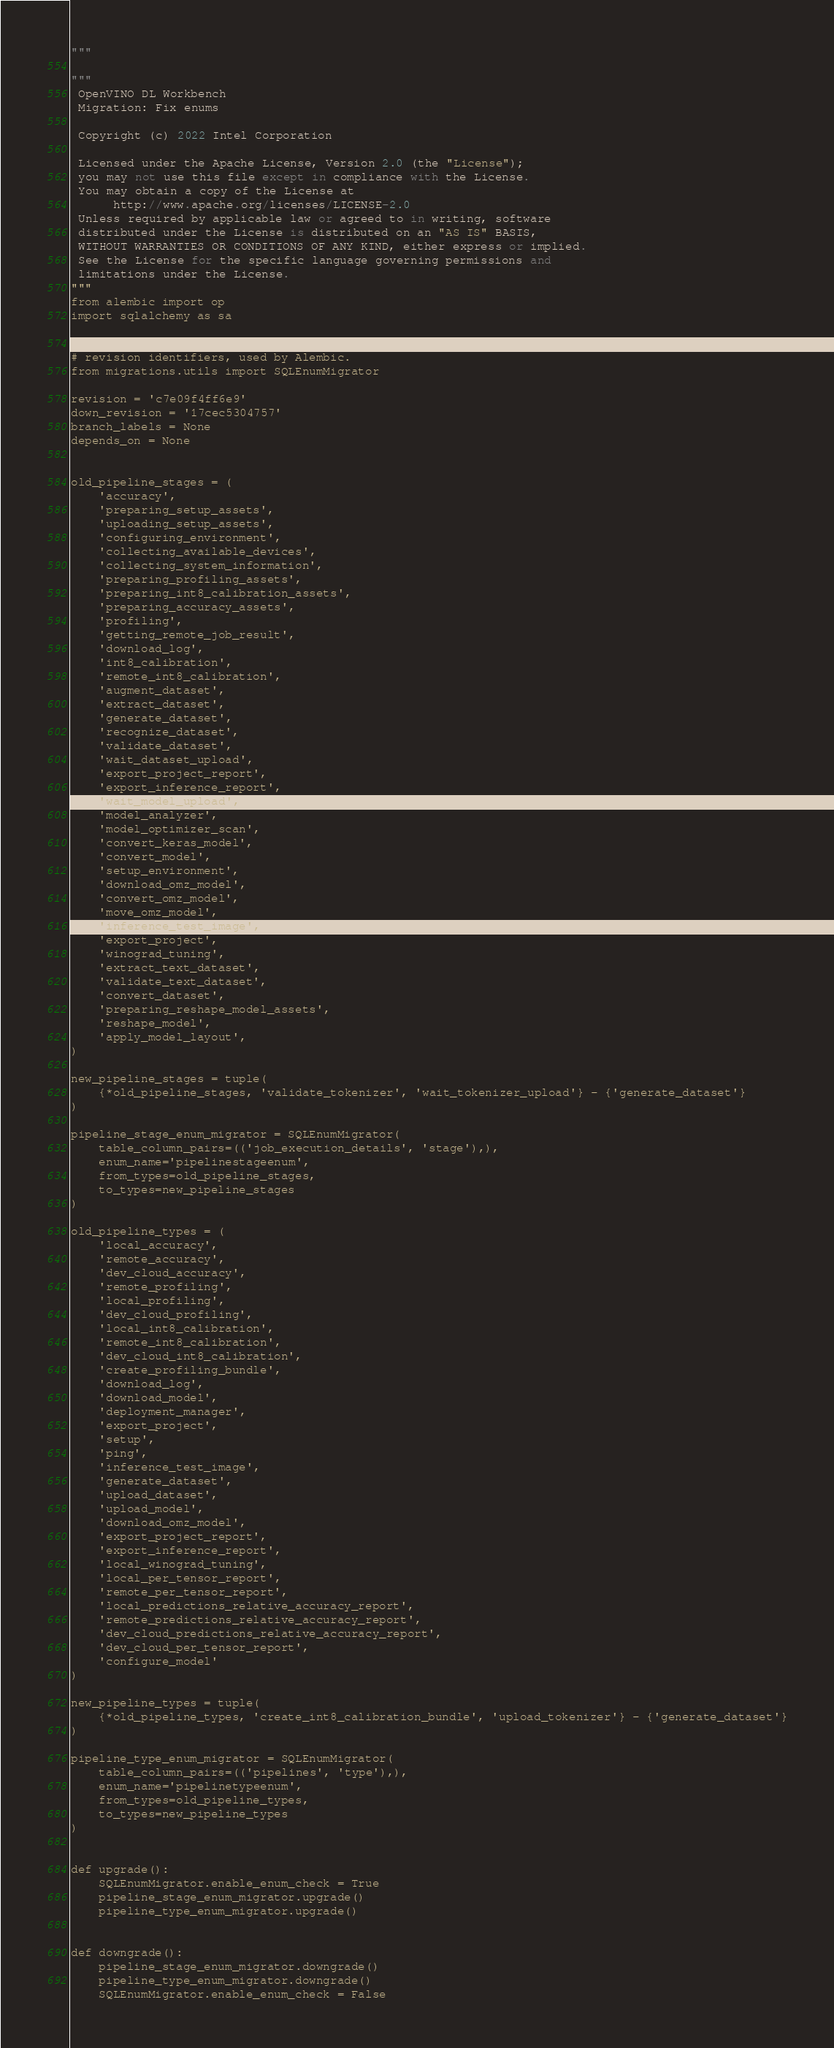Convert code to text. <code><loc_0><loc_0><loc_500><loc_500><_Python_>"""

"""
 OpenVINO DL Workbench
 Migration: Fix enums

 Copyright (c) 2022 Intel Corporation

 Licensed under the Apache License, Version 2.0 (the "License");
 you may not use this file except in compliance with the License.
 You may obtain a copy of the License at
      http://www.apache.org/licenses/LICENSE-2.0
 Unless required by applicable law or agreed to in writing, software
 distributed under the License is distributed on an "AS IS" BASIS,
 WITHOUT WARRANTIES OR CONDITIONS OF ANY KIND, either express or implied.
 See the License for the specific language governing permissions and
 limitations under the License.
"""
from alembic import op
import sqlalchemy as sa


# revision identifiers, used by Alembic.
from migrations.utils import SQLEnumMigrator

revision = 'c7e09f4ff6e9'
down_revision = '17cec5304757'
branch_labels = None
depends_on = None


old_pipeline_stages = (
    'accuracy',
    'preparing_setup_assets',
    'uploading_setup_assets',
    'configuring_environment',
    'collecting_available_devices',
    'collecting_system_information',
    'preparing_profiling_assets',
    'preparing_int8_calibration_assets',
    'preparing_accuracy_assets',
    'profiling',
    'getting_remote_job_result',
    'download_log',
    'int8_calibration',
    'remote_int8_calibration',
    'augment_dataset',
    'extract_dataset',
    'generate_dataset',
    'recognize_dataset',
    'validate_dataset',
    'wait_dataset_upload',
    'export_project_report',
    'export_inference_report',
    'wait_model_upload',
    'model_analyzer',
    'model_optimizer_scan',
    'convert_keras_model',
    'convert_model',
    'setup_environment',
    'download_omz_model',
    'convert_omz_model',
    'move_omz_model',
    'inference_test_image',
    'export_project',
    'winograd_tuning',
    'extract_text_dataset',
    'validate_text_dataset',
    'convert_dataset',
    'preparing_reshape_model_assets',
    'reshape_model',
    'apply_model_layout',
)

new_pipeline_stages = tuple(
    {*old_pipeline_stages, 'validate_tokenizer', 'wait_tokenizer_upload'} - {'generate_dataset'}
)

pipeline_stage_enum_migrator = SQLEnumMigrator(
    table_column_pairs=(('job_execution_details', 'stage'),),
    enum_name='pipelinestageenum',
    from_types=old_pipeline_stages,
    to_types=new_pipeline_stages
)

old_pipeline_types = (
    'local_accuracy',
    'remote_accuracy',
    'dev_cloud_accuracy',
    'remote_profiling',
    'local_profiling',
    'dev_cloud_profiling',
    'local_int8_calibration',
    'remote_int8_calibration',
    'dev_cloud_int8_calibration',
    'create_profiling_bundle',
    'download_log',
    'download_model',
    'deployment_manager',
    'export_project',
    'setup',
    'ping',
    'inference_test_image',
    'generate_dataset',
    'upload_dataset',
    'upload_model',
    'download_omz_model',
    'export_project_report',
    'export_inference_report',
    'local_winograd_tuning',
    'local_per_tensor_report',
    'remote_per_tensor_report',
    'local_predictions_relative_accuracy_report',
    'remote_predictions_relative_accuracy_report',
    'dev_cloud_predictions_relative_accuracy_report',
    'dev_cloud_per_tensor_report',
    'configure_model'
)

new_pipeline_types = tuple(
    {*old_pipeline_types, 'create_int8_calibration_bundle', 'upload_tokenizer'} - {'generate_dataset'}
)

pipeline_type_enum_migrator = SQLEnumMigrator(
    table_column_pairs=(('pipelines', 'type'),),
    enum_name='pipelinetypeenum',
    from_types=old_pipeline_types,
    to_types=new_pipeline_types
)


def upgrade():
    SQLEnumMigrator.enable_enum_check = True
    pipeline_stage_enum_migrator.upgrade()
    pipeline_type_enum_migrator.upgrade()


def downgrade():
    pipeline_stage_enum_migrator.downgrade()
    pipeline_type_enum_migrator.downgrade()
    SQLEnumMigrator.enable_enum_check = False
</code> 